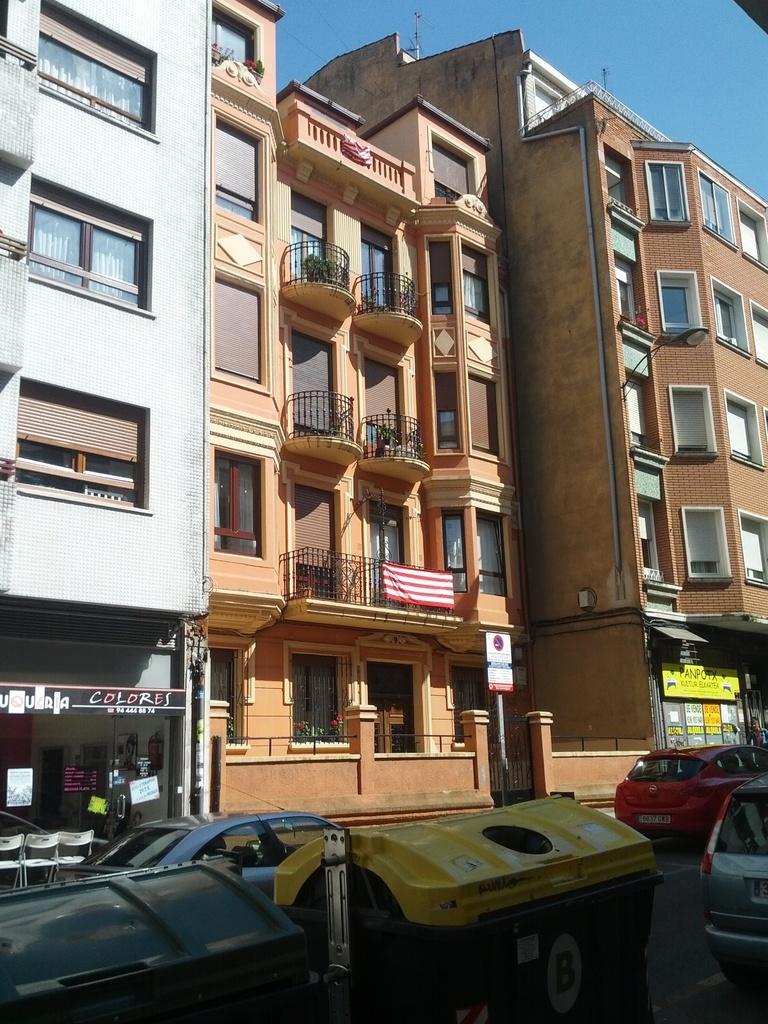Please provide a concise description of this image. In this image I can see the vehicles on the road. In the background I can see the buildings with windows and railing. I can see the boards attached to the buildings. In the background I can see the blue sky. 